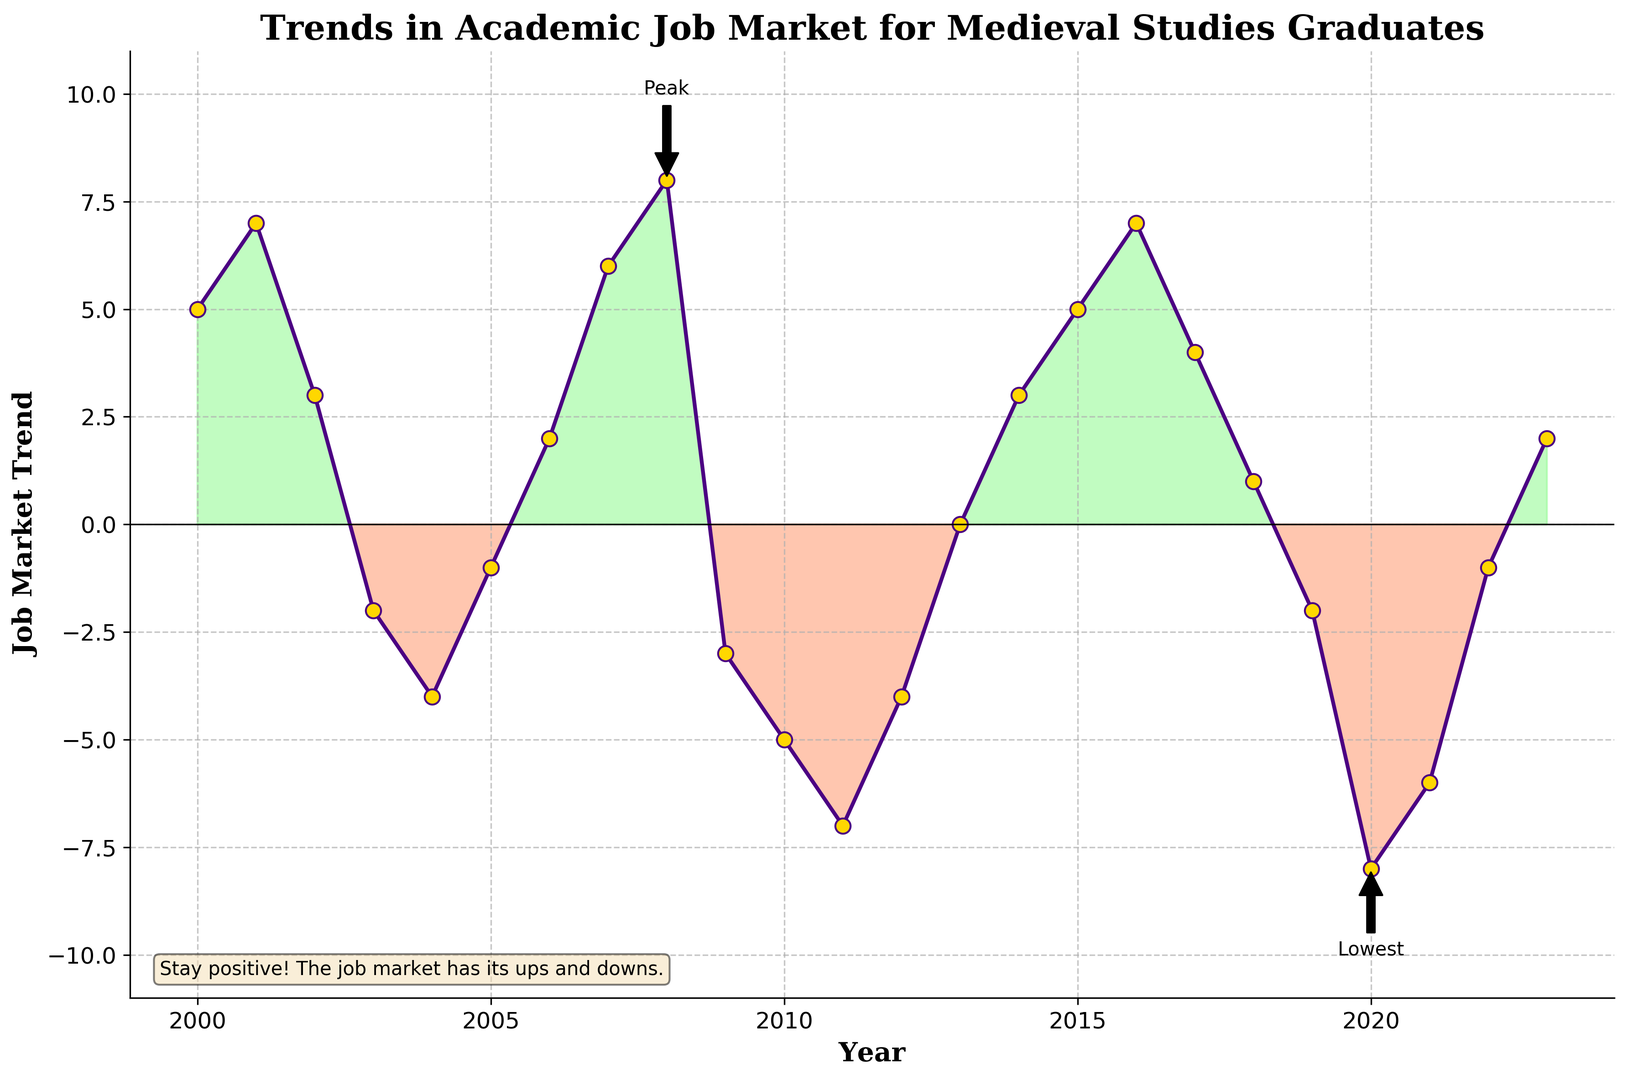How did the job market trend change from its lowest point to the latest year? The lowest point was in 2020 with a value of -8, and the latest year, 2023, has a value of 2. The change is 2 - (-8) = 2 + 8 = 10.
Answer: 10 How many years did the job market trend stay negative? By visually inspecting the graph, the job market trend was negative in 2003, 2004, 2005, 2009, 2010, 2011, 2012, 2019, 2020, and 2021. There are 10 years in total.
Answer: 10 What year had the peak value in the job market trend? The peak value is annotated on the graph. The year is 2008 with a job market trend of 8.
Answer: 2008 Which period showed the longest consecutive decline in the job market trend without any increases? There was a continuous decline from 2008 (8) to 2011 (-7), which is four consecutive years.
Answer: 2008 to 2011 How many years showed a job market trend of zero or higher? By inspecting the graph, the following years had zero or positive values: 2000, 2001, 2002, 2006, 2007, 2008, 2013, 2014, 2015, 2016, 2017, 2018, and 2023. There are 13 years in total.
Answer: 13 Which year showed the largest year-to-year drop in the job market trend? From 2008 to 2009, the value dropped from 8 to -3, which is a drop of 8 - (-3) = 8 + 3 = 11.
Answer: 2008 to 2009 How did the job market trend change from 2016 to 2018? In 2016, the trend was 7 and in 2018 it was 1. The change is 1 - 7 = -6.
Answer: -6 In which year did the job market trend first become negative? By inspecting the graph, the job market trend first became negative in 2003.
Answer: 2003 What is the average job market trend from 2020 to 2023? The job market trend values for these years are -8, -6, -1, and 2. The sum of these values is -8 + (-6) + (-1) + 2 = -13. The average is -13 / 4 = -3.25.
Answer: -3.25 